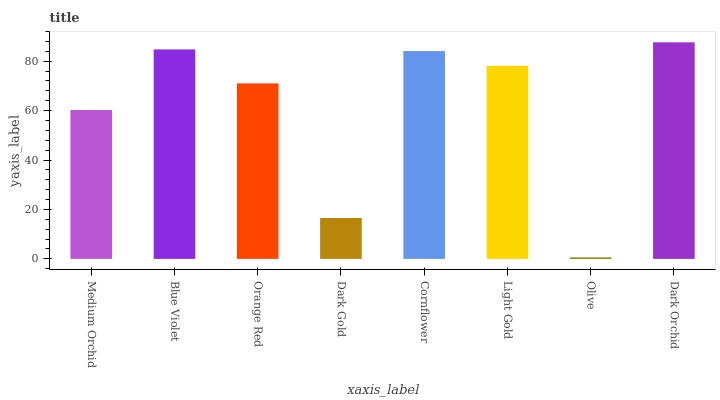Is Blue Violet the minimum?
Answer yes or no. No. Is Blue Violet the maximum?
Answer yes or no. No. Is Blue Violet greater than Medium Orchid?
Answer yes or no. Yes. Is Medium Orchid less than Blue Violet?
Answer yes or no. Yes. Is Medium Orchid greater than Blue Violet?
Answer yes or no. No. Is Blue Violet less than Medium Orchid?
Answer yes or no. No. Is Light Gold the high median?
Answer yes or no. Yes. Is Orange Red the low median?
Answer yes or no. Yes. Is Blue Violet the high median?
Answer yes or no. No. Is Medium Orchid the low median?
Answer yes or no. No. 